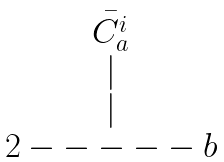<formula> <loc_0><loc_0><loc_500><loc_500>\begin{matrix} \bar { C _ { a } ^ { i } } \\ | \\ | \\ 2 - - - - - b \end{matrix}</formula> 